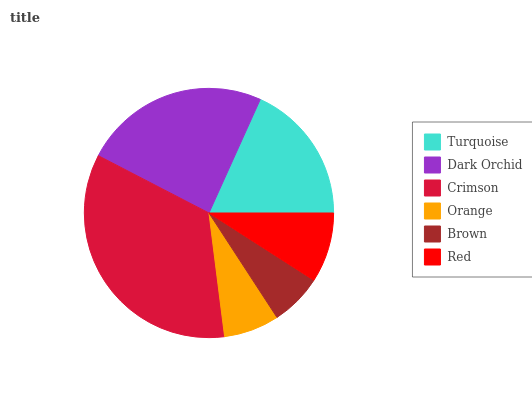Is Brown the minimum?
Answer yes or no. Yes. Is Crimson the maximum?
Answer yes or no. Yes. Is Dark Orchid the minimum?
Answer yes or no. No. Is Dark Orchid the maximum?
Answer yes or no. No. Is Dark Orchid greater than Turquoise?
Answer yes or no. Yes. Is Turquoise less than Dark Orchid?
Answer yes or no. Yes. Is Turquoise greater than Dark Orchid?
Answer yes or no. No. Is Dark Orchid less than Turquoise?
Answer yes or no. No. Is Turquoise the high median?
Answer yes or no. Yes. Is Red the low median?
Answer yes or no. Yes. Is Orange the high median?
Answer yes or no. No. Is Orange the low median?
Answer yes or no. No. 